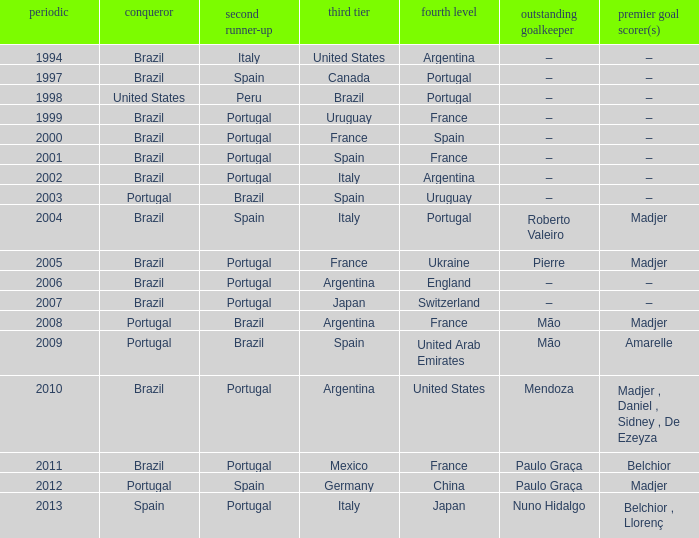Who were the winners in 1998? United States. 